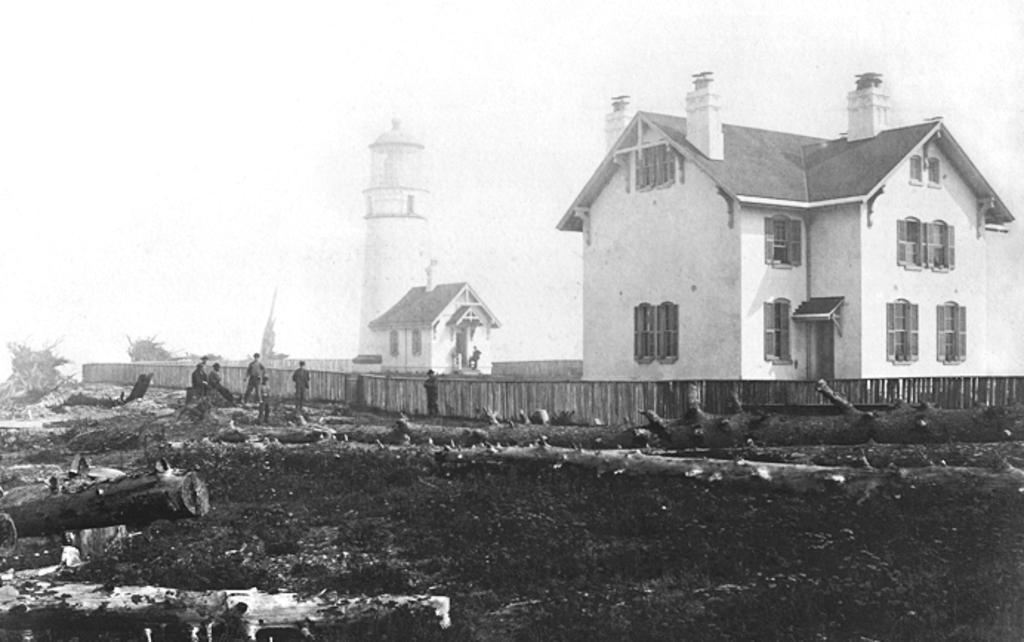Describe this image in one or two sentences. In this image there are wooden logs on the surface. On the backside of the image there are buildings. In front of the building there is a wooden fence. There are a few people standing on the ground. In the background there is a lighthouse and sky. 